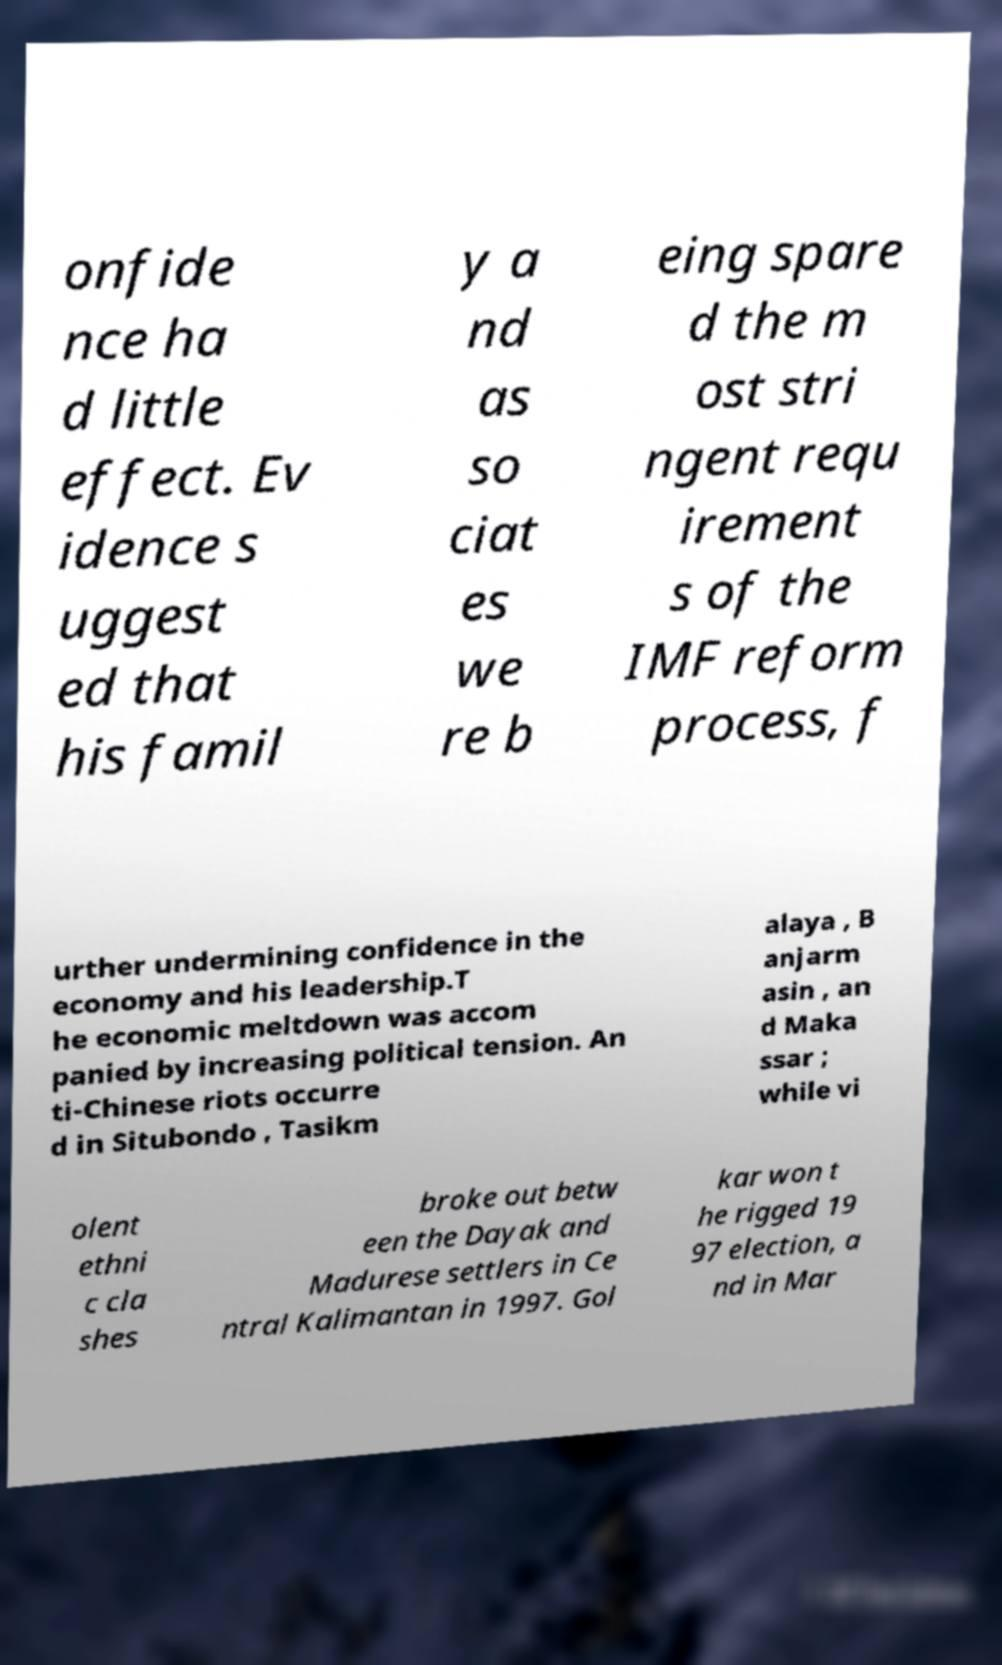Please identify and transcribe the text found in this image. onfide nce ha d little effect. Ev idence s uggest ed that his famil y a nd as so ciat es we re b eing spare d the m ost stri ngent requ irement s of the IMF reform process, f urther undermining confidence in the economy and his leadership.T he economic meltdown was accom panied by increasing political tension. An ti-Chinese riots occurre d in Situbondo , Tasikm alaya , B anjarm asin , an d Maka ssar ; while vi olent ethni c cla shes broke out betw een the Dayak and Madurese settlers in Ce ntral Kalimantan in 1997. Gol kar won t he rigged 19 97 election, a nd in Mar 